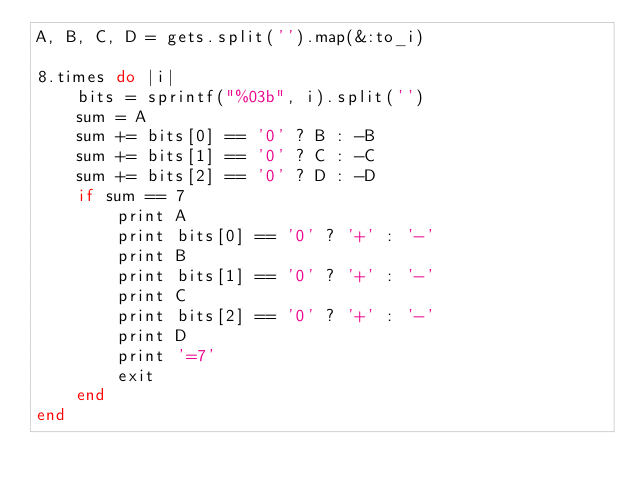Convert code to text. <code><loc_0><loc_0><loc_500><loc_500><_Ruby_>A, B, C, D = gets.split('').map(&:to_i)

8.times do |i|
    bits = sprintf("%03b", i).split('')
    sum = A
    sum += bits[0] == '0' ? B : -B
    sum += bits[1] == '0' ? C : -C
    sum += bits[2] == '0' ? D : -D
    if sum == 7
        print A
        print bits[0] == '0' ? '+' : '-'
        print B
        print bits[1] == '0' ? '+' : '-'
        print C
        print bits[2] == '0' ? '+' : '-'
        print D
        print '=7'
        exit
    end
end</code> 